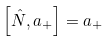<formula> <loc_0><loc_0><loc_500><loc_500>\left [ \hat { N } , a _ { + } \right ] = a _ { + }</formula> 